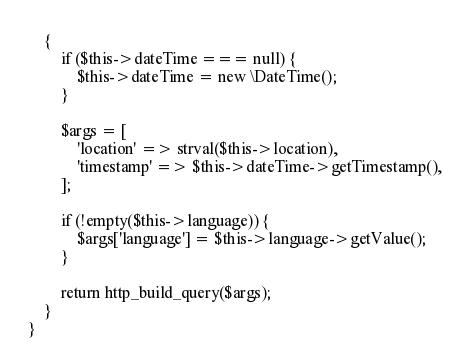Convert code to text. <code><loc_0><loc_0><loc_500><loc_500><_PHP_>    {
        if ($this->dateTime === null) {
            $this->dateTime = new \DateTime();
        }

        $args = [
            'location' => strval($this->location),
            'timestamp' => $this->dateTime->getTimestamp(),
        ];

        if (!empty($this->language)) {
            $args['language'] = $this->language->getValue();
        }

        return http_build_query($args);
    }
}
</code> 